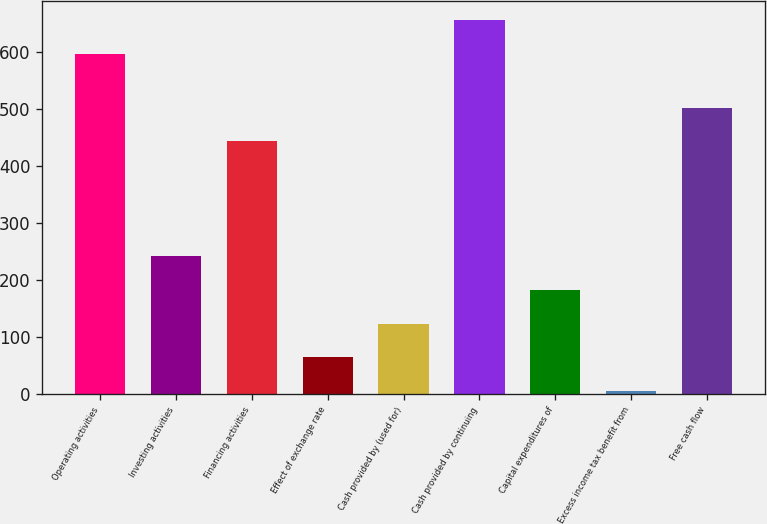Convert chart. <chart><loc_0><loc_0><loc_500><loc_500><bar_chart><fcel>Operating activities<fcel>Investing activities<fcel>Financing activities<fcel>Effect of exchange rate<fcel>Cash provided by (used for)<fcel>Cash provided by continuing<fcel>Capital expenditures of<fcel>Excess income tax benefit from<fcel>Free cash flow<nl><fcel>596.8<fcel>241.48<fcel>442.8<fcel>63.82<fcel>123.04<fcel>656.02<fcel>182.26<fcel>4.6<fcel>502.02<nl></chart> 